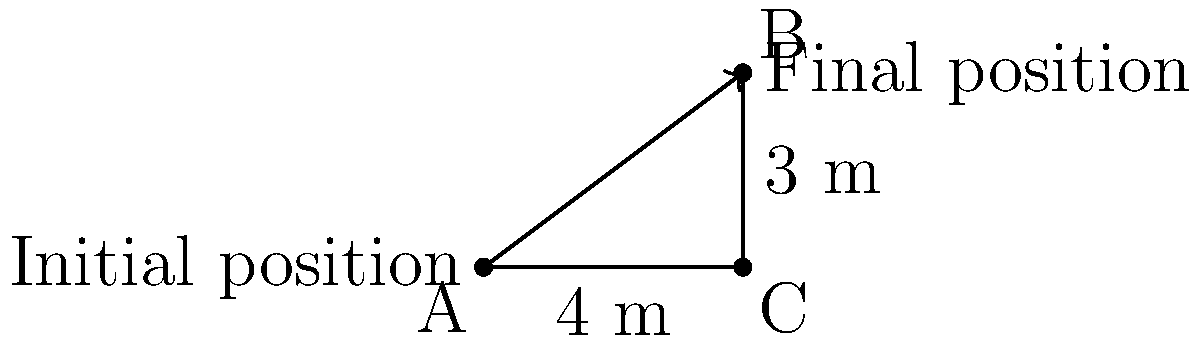In a judo match, British judoka Ashley McKenzie performs a throw. The diagram shows the initial and final positions of his opponent. If the horizontal distance covered is 4 meters and the vertical distance is 3 meters, what is the angle of the throw with respect to the horizontal? To find the angle of the throw, we need to use trigonometry. The diagram forms a right-angled triangle, where:

1. The adjacent side (horizontal distance) is 4 meters
2. The opposite side (vertical distance) is 3 meters
3. The hypotenuse represents the path of the throw

We can use the arctangent function to calculate the angle:

$$\theta = \arctan(\frac{\text{opposite}}{\text{adjacent}})$$

Substituting the values:

$$\theta = \arctan(\frac{3}{4})$$

Using a calculator or trigonometric tables:

$$\theta \approx 36.87^\circ$$

Therefore, the angle of the throw with respect to the horizontal is approximately 36.87 degrees.
Answer: 36.87° 